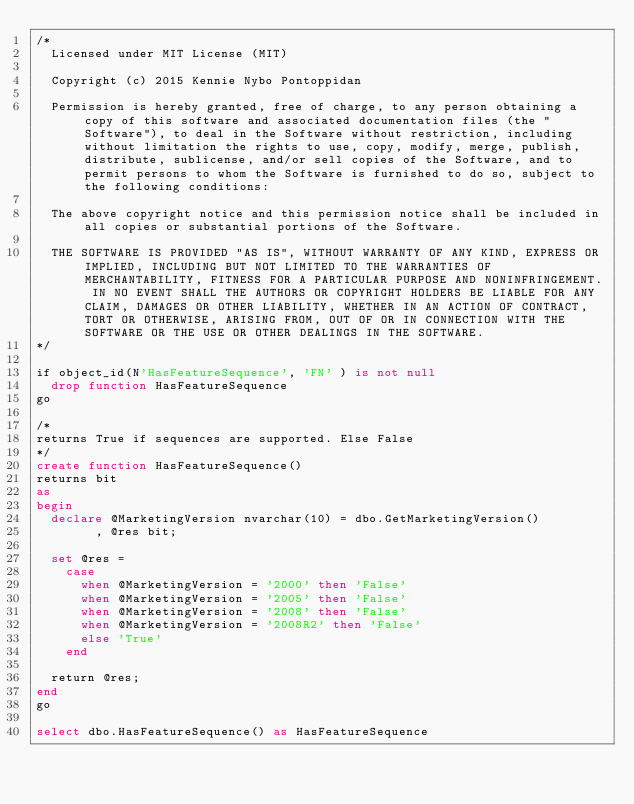<code> <loc_0><loc_0><loc_500><loc_500><_SQL_>/* 
  Licensed under MIT License (MIT)

  Copyright (c) 2015 Kennie Nybo Pontoppidan

  Permission is hereby granted, free of charge, to any person obtaining a copy of this software and associated documentation files (the "Software"), to deal in the Software without restriction, including without limitation the rights to use, copy, modify, merge, publish, distribute, sublicense, and/or sell copies of the Software, and to permit persons to whom the Software is furnished to do so, subject to the following conditions:

  The above copyright notice and this permission notice shall be included in all copies or substantial portions of the Software.

  THE SOFTWARE IS PROVIDED "AS IS", WITHOUT WARRANTY OF ANY KIND, EXPRESS OR IMPLIED, INCLUDING BUT NOT LIMITED TO THE WARRANTIES OF MERCHANTABILITY, FITNESS FOR A PARTICULAR PURPOSE AND NONINFRINGEMENT. IN NO EVENT SHALL THE AUTHORS OR COPYRIGHT HOLDERS BE LIABLE FOR ANY CLAIM, DAMAGES OR OTHER LIABILITY, WHETHER IN AN ACTION OF CONTRACT, TORT OR OTHERWISE, ARISING FROM, OUT OF OR IN CONNECTION WITH THE SOFTWARE OR THE USE OR OTHER DEALINGS IN THE SOFTWARE.  
*/

if object_id(N'HasFeatureSequence', 'FN' ) is not null
  drop function HasFeatureSequence
go

/*
returns True if sequences are supported. Else False
*/
create function HasFeatureSequence()
returns bit
as
begin 
  declare @MarketingVersion nvarchar(10) = dbo.GetMarketingVersion()
        , @res bit;

  set @res = 
    case 
      when @MarketingVersion = '2000' then 'False'
      when @MarketingVersion = '2005' then 'False'
      when @MarketingVersion = '2008' then 'False'
      when @MarketingVersion = '2008R2' then 'False'
      else 'True'
    end

  return @res;
end
go

select dbo.HasFeatureSequence() as HasFeatureSequence
</code> 